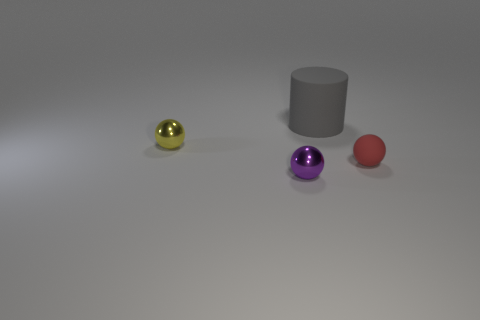There is a object in front of the object to the right of the big matte cylinder; is there a tiny purple sphere that is right of it?
Ensure brevity in your answer.  No. Do the red rubber object and the yellow metallic thing have the same size?
Offer a very short reply. Yes. Are there an equal number of purple things on the right side of the small purple sphere and small yellow balls that are in front of the tiny yellow thing?
Make the answer very short. Yes. There is a tiny red object that is to the right of the small purple object; what shape is it?
Offer a terse response. Sphere. There is a tiny sphere on the right side of the object that is in front of the thing on the right side of the gray matte object; what is its color?
Make the answer very short. Red. Does the small purple object have the same shape as the big gray rubber object?
Give a very brief answer. No. Are there the same number of red matte balls that are in front of the tiny red object and big gray things?
Your response must be concise. No. What number of other objects are the same material as the big cylinder?
Offer a very short reply. 1. There is a ball that is in front of the red thing; is its size the same as the object that is behind the tiny yellow metallic sphere?
Your response must be concise. No. How many objects are either tiny spheres that are behind the tiny purple shiny thing or objects left of the gray object?
Ensure brevity in your answer.  3. 